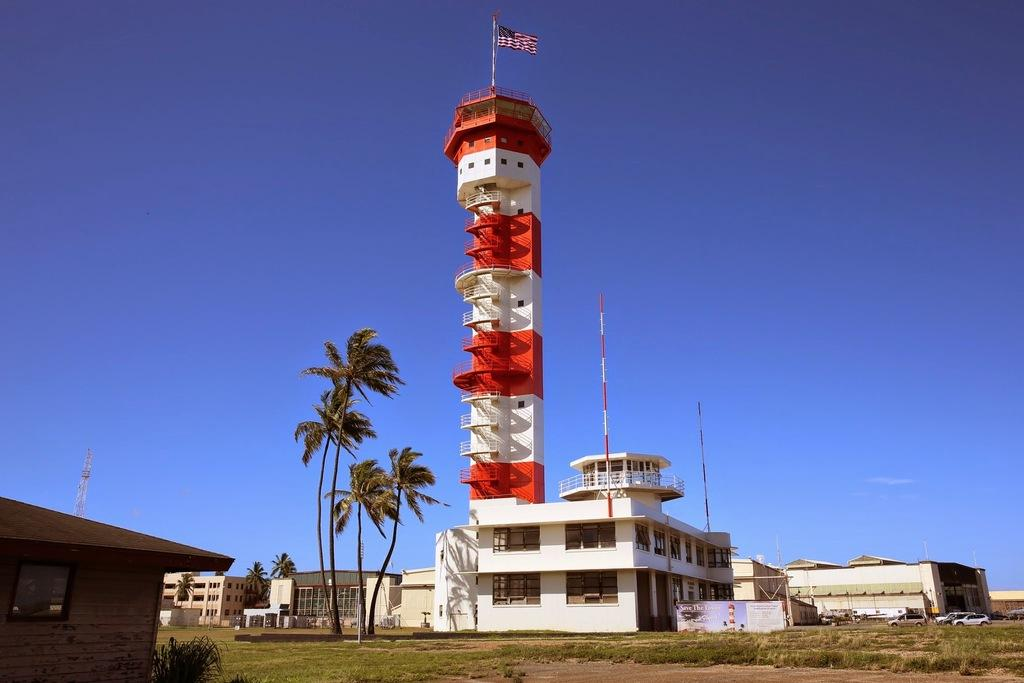What type of structures can be seen in the image? There are houses and buildings in the image. Can you describe the tallest structure in the image? There is a tall building in the image, and it has a flag on it. What type of vegetation is present in the image? There are trees and plants in the image. What letter is written on the screw that is holding the flag in place? There is no screw or letter mentioned in the image; it only states that there is a flag on the tall building. 